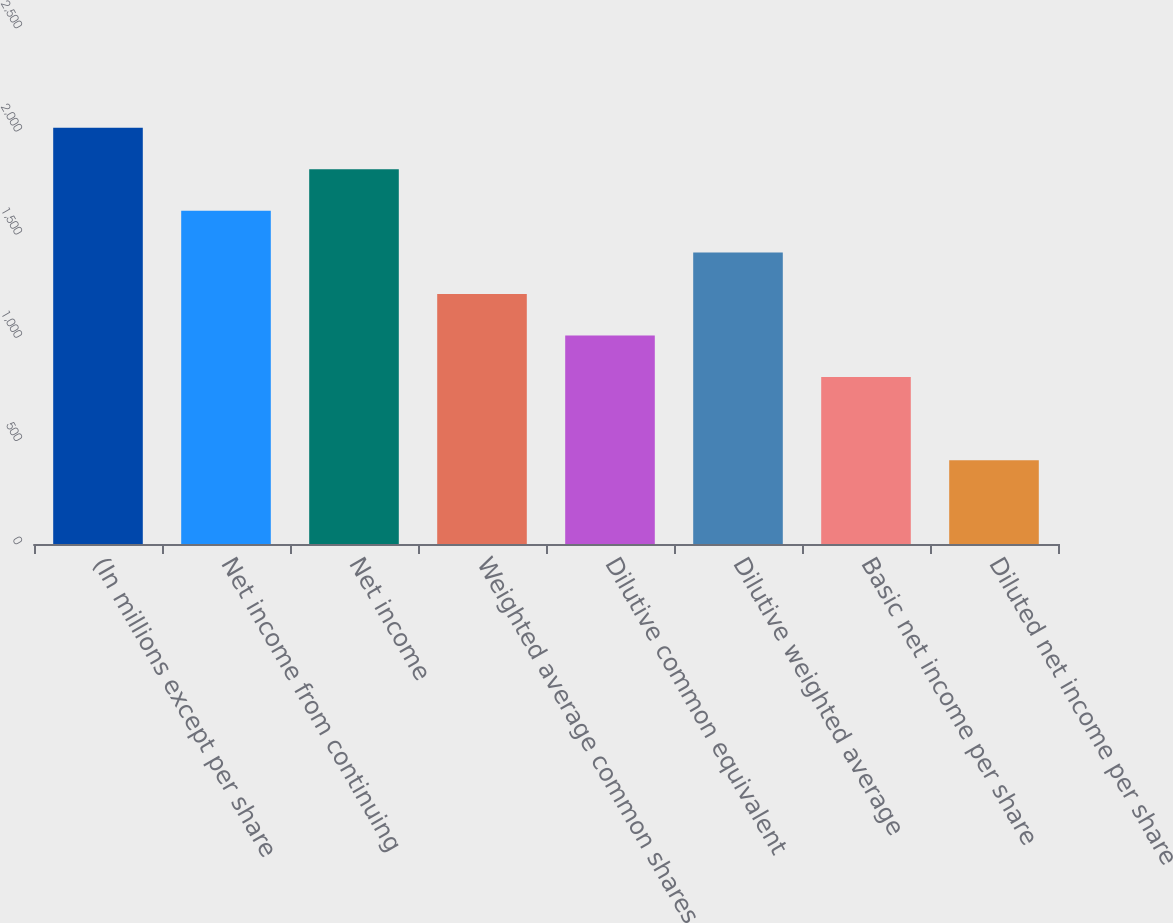<chart> <loc_0><loc_0><loc_500><loc_500><bar_chart><fcel>(In millions except per share<fcel>Net income from continuing<fcel>Net income<fcel>Weighted average common shares<fcel>Dilutive common equivalent<fcel>Dilutive weighted average<fcel>Basic net income per share<fcel>Diluted net income per share<nl><fcel>2017<fcel>1614.2<fcel>1815.6<fcel>1211.4<fcel>1010<fcel>1412.8<fcel>808.6<fcel>405.8<nl></chart> 